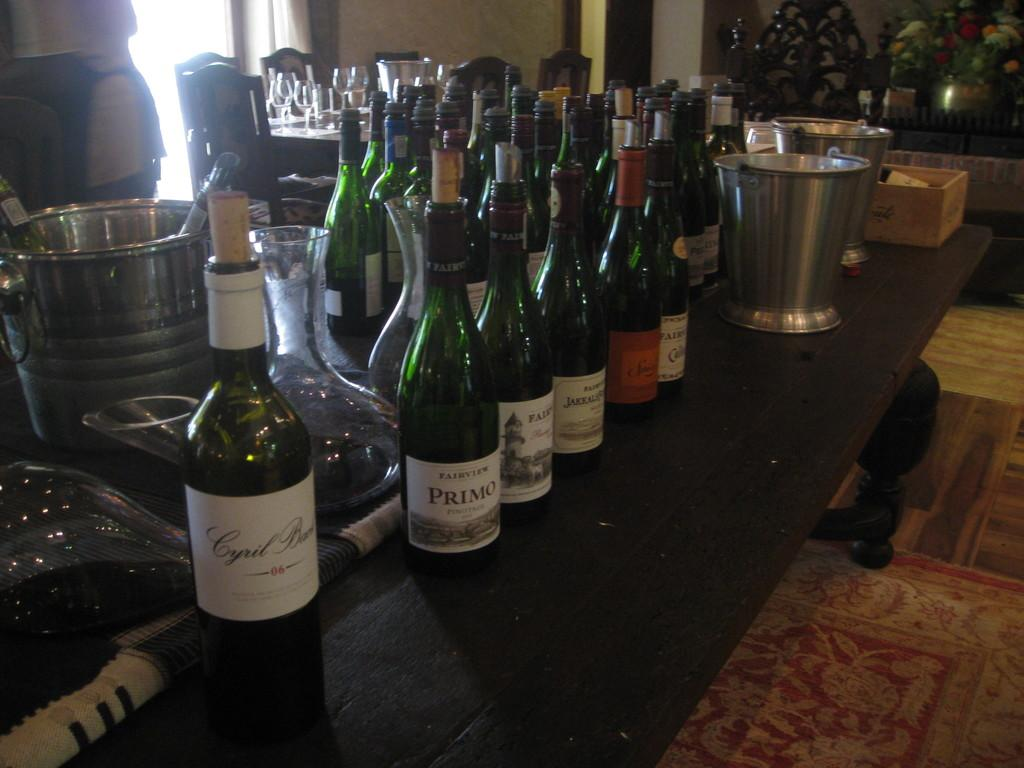Provide a one-sentence caption for the provided image. Bottles of wine are on a bar and one of them is Primo. 